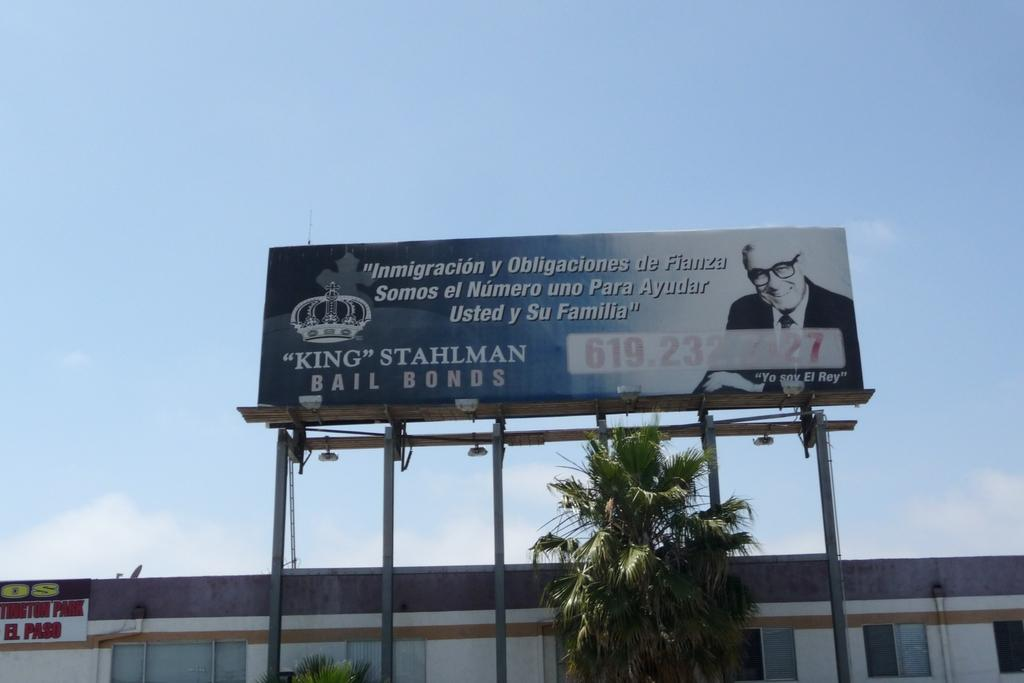<image>
Create a compact narrative representing the image presented. A large bill board with the word king stahlam written on it. 